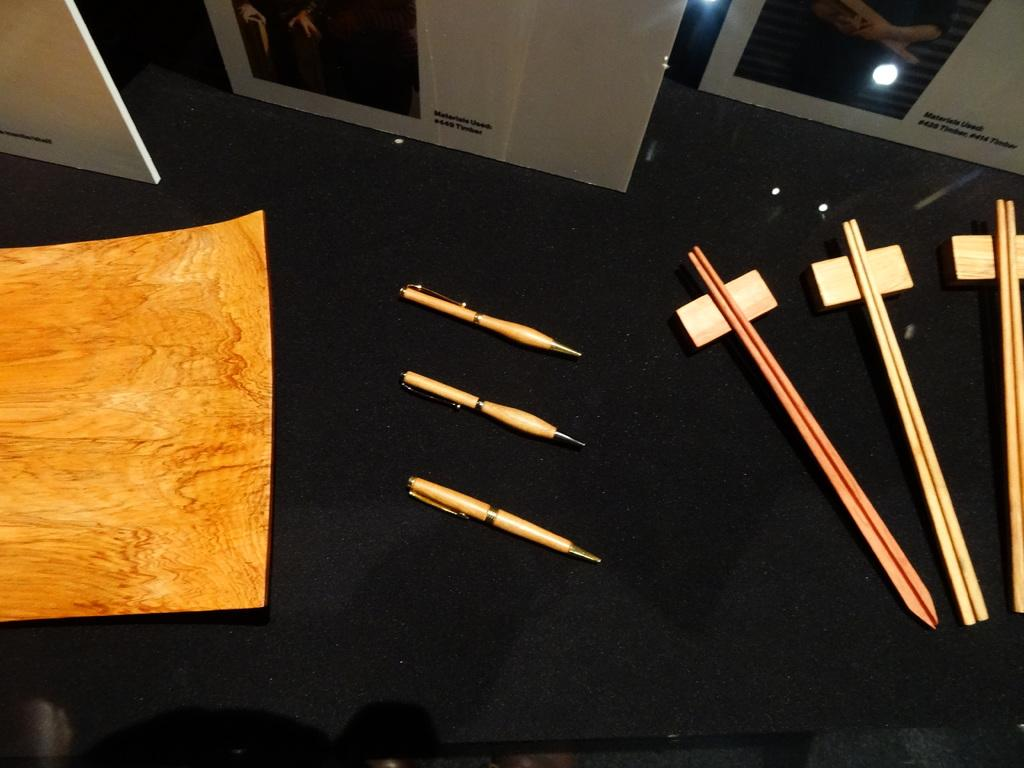Where was the image taken? The image was taken inside a room. What color is the table or desk in the image? The table or desk in the image is black. What items can be seen on the table or desk? There are pens, sticks, cardboards, and posters or frames on the table or desk. What type of tin can be seen on the table or desk in the image? There is no tin present on the table or desk in the image. What shape is the cover on the table or desk in the image? There is no cover present on the table or desk in the image. 